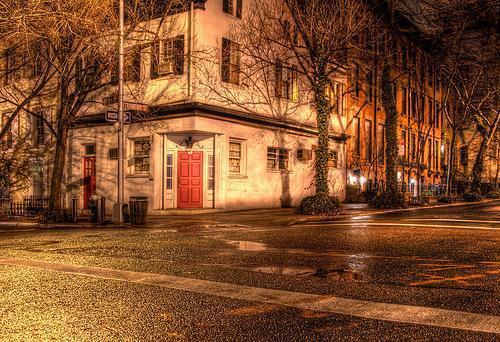How many trees are falling down to the ground?
Give a very brief answer. 0. 